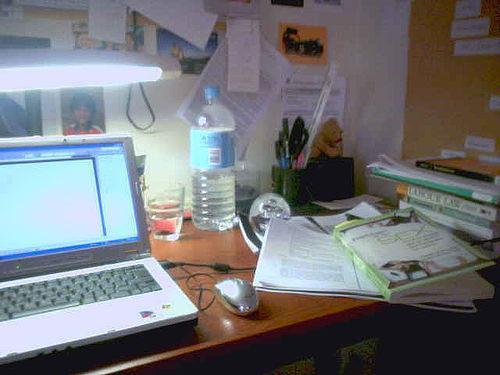How many computers are on?
Give a very brief answer. 1. How many pens are in the picture?
Give a very brief answer. 2. How many books are visible?
Give a very brief answer. 2. How many horses are in the picture?
Give a very brief answer. 0. 